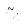Convert formula to latex. <formula><loc_0><loc_0><loc_500><loc_500>\tilde { u } _ { i }</formula> 